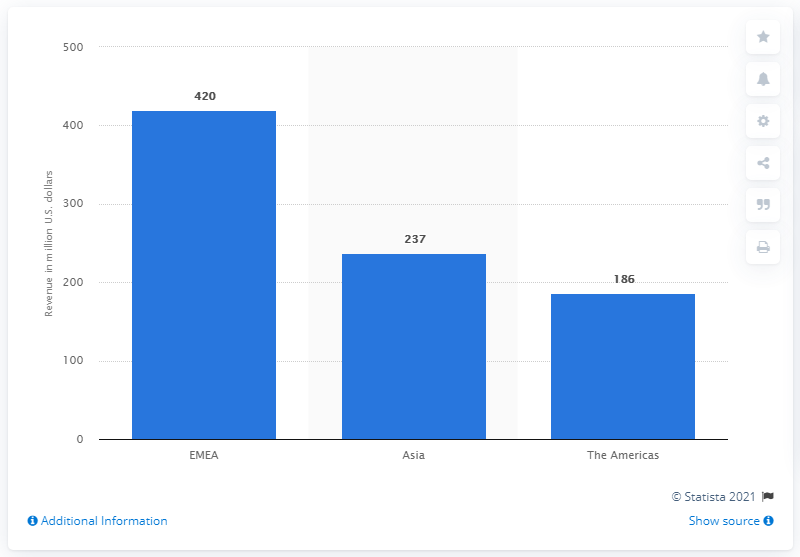Specify some key components in this picture. In fiscal year 2020, the revenue generated by Versace's EMEA region was 420 million dollars. 